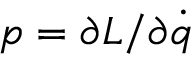Convert formula to latex. <formula><loc_0><loc_0><loc_500><loc_500>p = \partial L / \partial { \dot { q } }</formula> 